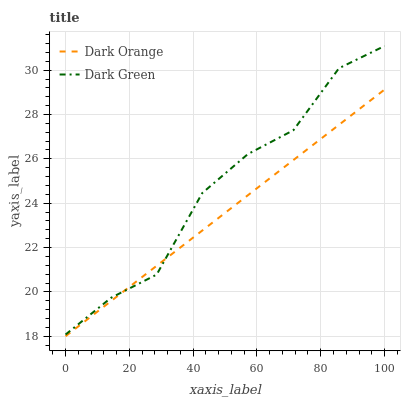Does Dark Orange have the minimum area under the curve?
Answer yes or no. Yes. Does Dark Green have the maximum area under the curve?
Answer yes or no. Yes. Does Dark Green have the minimum area under the curve?
Answer yes or no. No. Is Dark Orange the smoothest?
Answer yes or no. Yes. Is Dark Green the roughest?
Answer yes or no. Yes. Is Dark Green the smoothest?
Answer yes or no. No. Does Dark Orange have the lowest value?
Answer yes or no. Yes. Does Dark Green have the lowest value?
Answer yes or no. No. Does Dark Green have the highest value?
Answer yes or no. Yes. Does Dark Orange intersect Dark Green?
Answer yes or no. Yes. Is Dark Orange less than Dark Green?
Answer yes or no. No. Is Dark Orange greater than Dark Green?
Answer yes or no. No. 